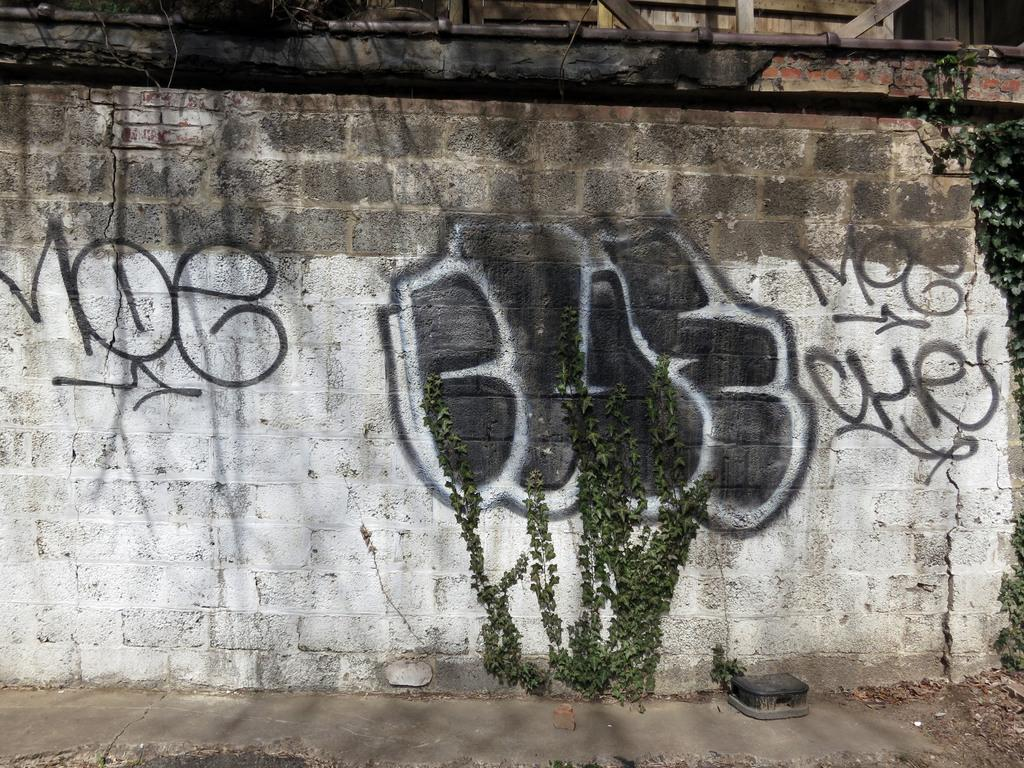What is a prominent feature in the image? There is a wall in the image. What is on the wall? There is writing or drawing on the wall. What else can be seen in the image? There are plants present in the image. What type of dress is the error wearing in the image? There is no error or dress present in the image. What is the error writing on the wall in the image? There is no error present in the image, and therefore no writing by an error can be observed. 